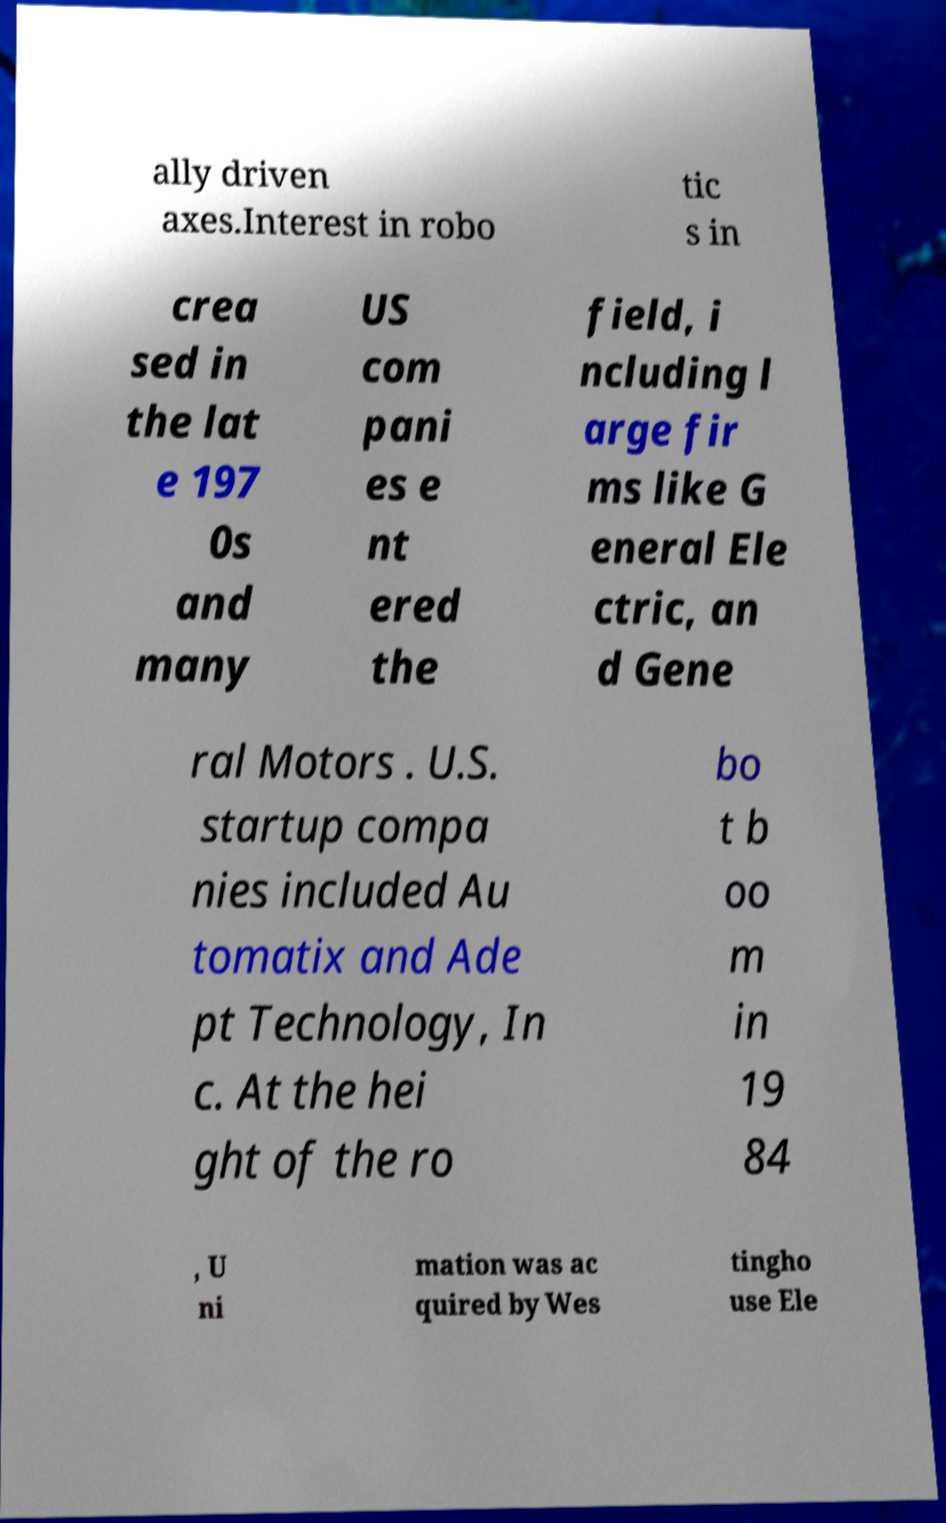I need the written content from this picture converted into text. Can you do that? ally driven axes.Interest in robo tic s in crea sed in the lat e 197 0s and many US com pani es e nt ered the field, i ncluding l arge fir ms like G eneral Ele ctric, an d Gene ral Motors . U.S. startup compa nies included Au tomatix and Ade pt Technology, In c. At the hei ght of the ro bo t b oo m in 19 84 , U ni mation was ac quired by Wes tingho use Ele 